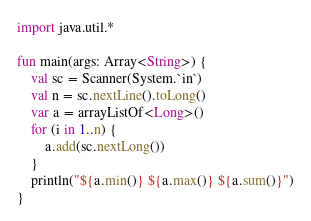<code> <loc_0><loc_0><loc_500><loc_500><_Kotlin_>import java.util.*

fun main(args: Array<String>) {
	val sc = Scanner(System.`in`)
	val n = sc.nextLine().toLong()
	var a = arrayListOf<Long>()
	for (i in 1..n) {
		a.add(sc.nextLong())
	}
	println("${a.min()} ${a.max()} ${a.sum()}")
}
</code> 